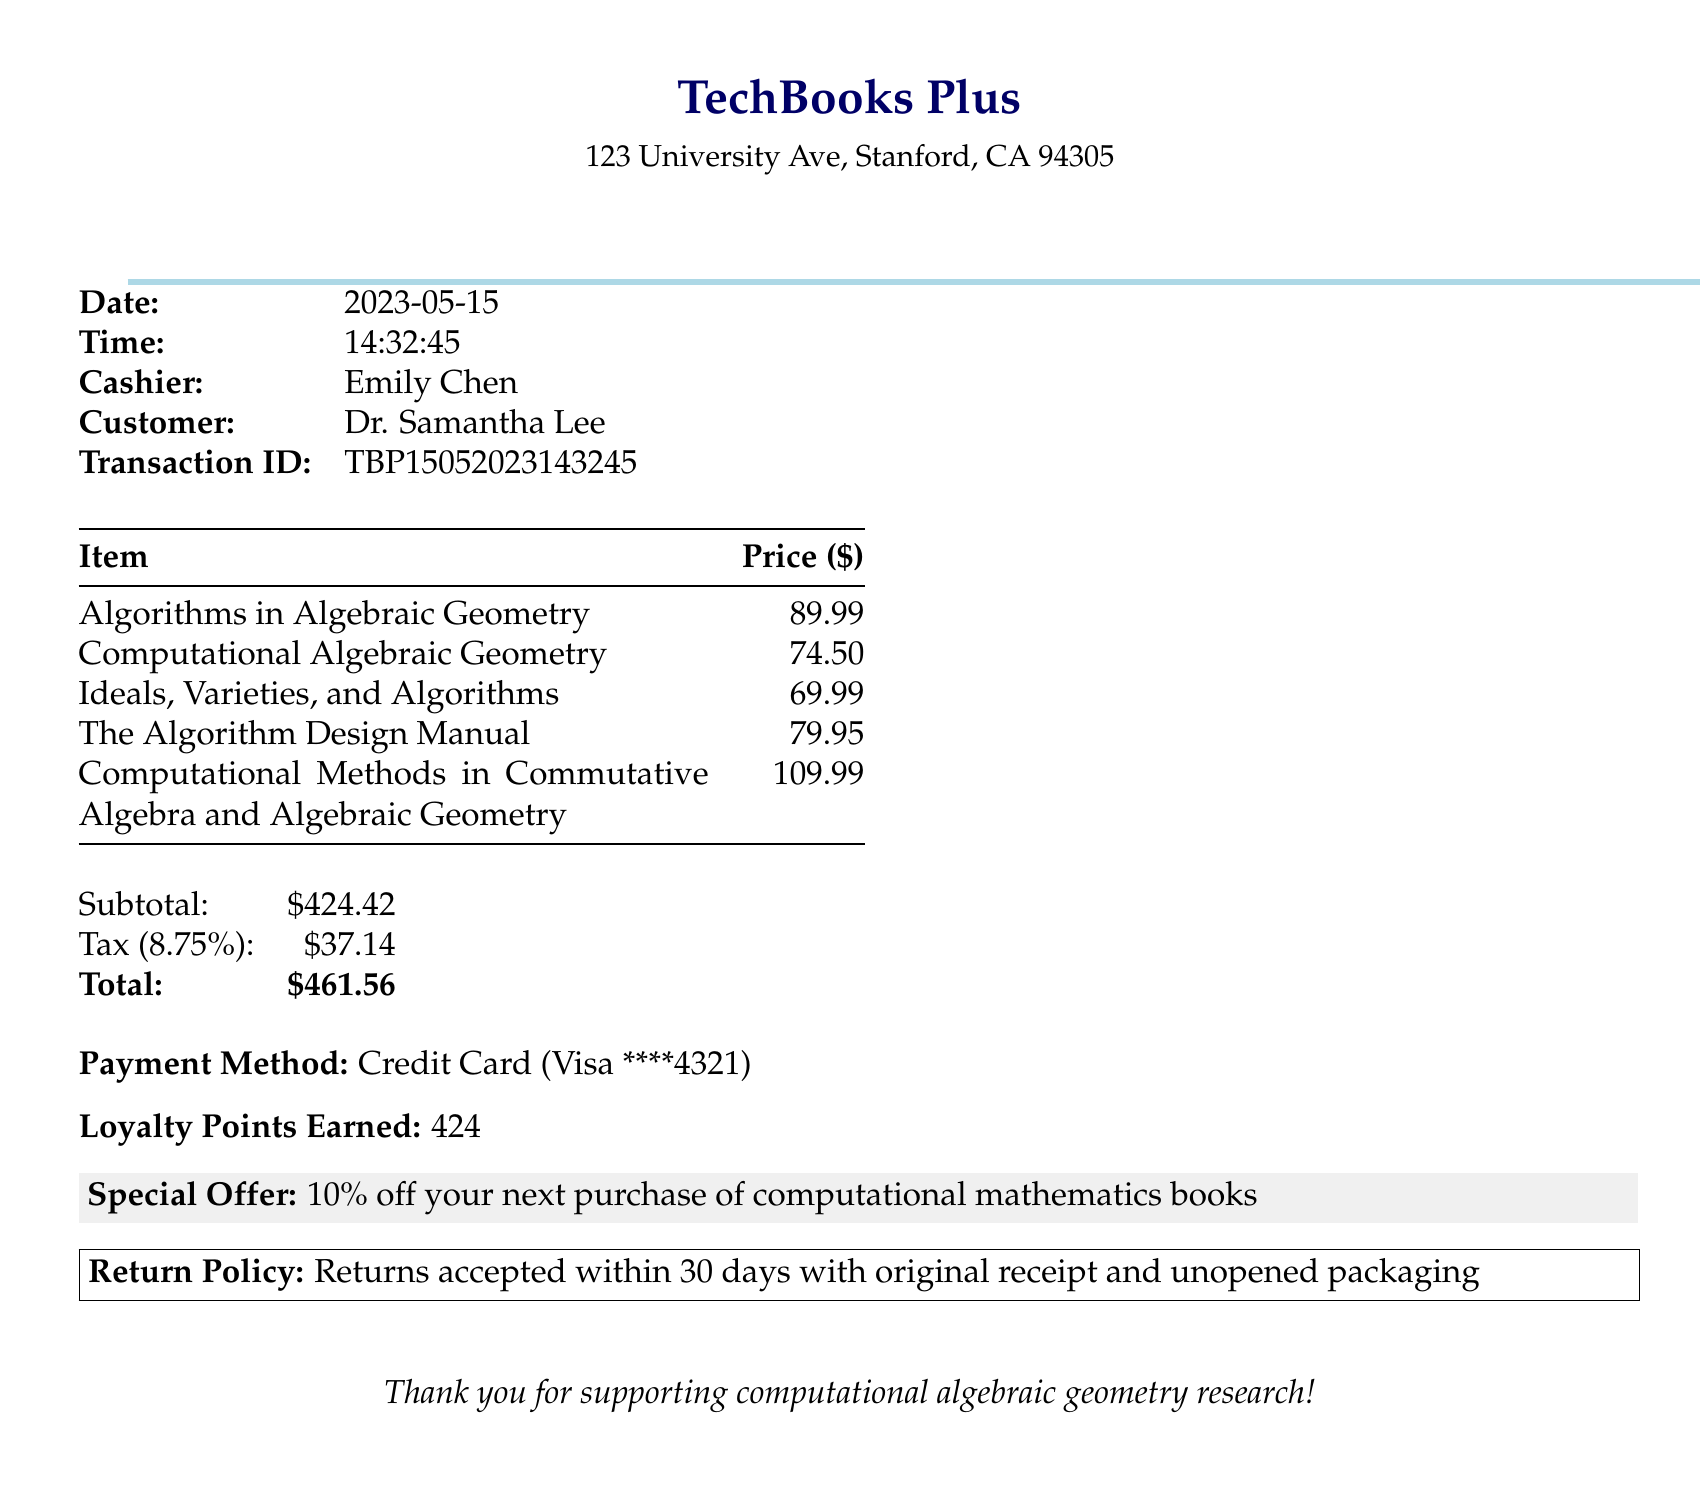what is the store name? The store name is presented at the top of the receipt, indicating where the purchase was made.
Answer: TechBooks Plus what is the date of the purchase? The date of the purchase is explicitly listed as part of the transaction details.
Answer: 2023-05-15 who is the author of "Algorithms in Algebraic Geometry"? The author's name is specified next to the title of the book on the receipt.
Answer: Bernd Sturmfels what is the total amount spent? The total amount is summarized at the end of the receipt after calculating the subtotal and tax.
Answer: $461.56 how much tax was applied to the purchase? The tax amount is clearly stated as part of the pricing breakdown.
Answer: $37.14 which payment method was used? The payment method is indicated in the document as part of the transaction details.
Answer: Credit Card what is the loyalty points earned from this purchase? The number of loyalty points earned is specified towards the end of the receipt.
Answer: 424 what is the special offer mentioned? The special offer is included in a highlighted section of the receipt and encourages future purchases.
Answer: 10% off your next purchase of computational mathematics books how many items were purchased in total? The receipt lists five individual items under the purchase section.
Answer: 5 